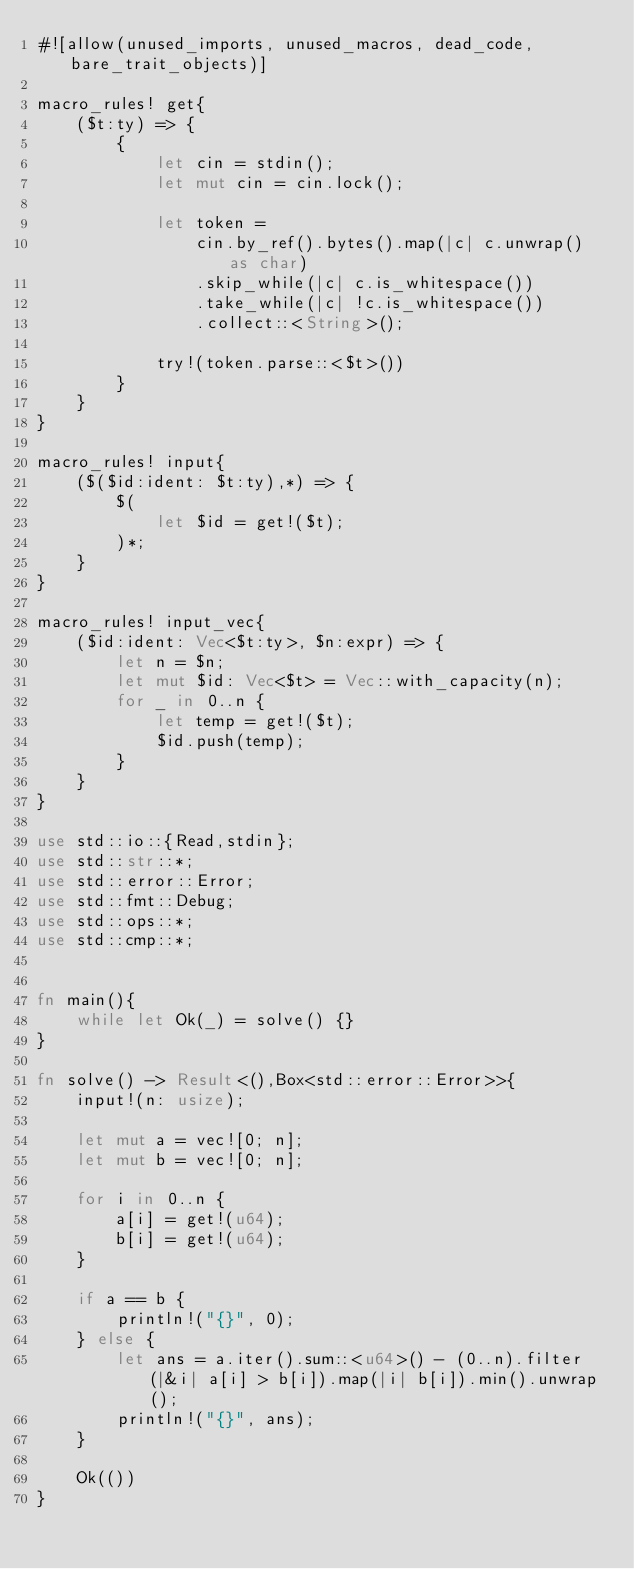<code> <loc_0><loc_0><loc_500><loc_500><_Rust_>#![allow(unused_imports, unused_macros, dead_code, bare_trait_objects)]

macro_rules! get{
    ($t:ty) => {
        {
            let cin = stdin();
            let mut cin = cin.lock();
            
            let token =
                cin.by_ref().bytes().map(|c| c.unwrap() as char)
                .skip_while(|c| c.is_whitespace())
                .take_while(|c| !c.is_whitespace())
                .collect::<String>();

            try!(token.parse::<$t>())
        }
    }
}

macro_rules! input{
    ($($id:ident: $t:ty),*) => {
        $(
            let $id = get!($t);
        )*;
    }
}

macro_rules! input_vec{
    ($id:ident: Vec<$t:ty>, $n:expr) => {
        let n = $n;
        let mut $id: Vec<$t> = Vec::with_capacity(n);
        for _ in 0..n {
            let temp = get!($t);
            $id.push(temp);
        }
    }
}

use std::io::{Read,stdin};
use std::str::*;
use std::error::Error;
use std::fmt::Debug;
use std::ops::*;
use std::cmp::*;


fn main(){
    while let Ok(_) = solve() {}
}

fn solve() -> Result<(),Box<std::error::Error>>{
    input!(n: usize);

    let mut a = vec![0; n];
    let mut b = vec![0; n];

    for i in 0..n {
        a[i] = get!(u64);
        b[i] = get!(u64);
    }

    if a == b {
        println!("{}", 0);
    } else {
        let ans = a.iter().sum::<u64>() - (0..n).filter(|&i| a[i] > b[i]).map(|i| b[i]).min().unwrap();
        println!("{}", ans);
    }

    Ok(())
}
</code> 